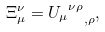Convert formula to latex. <formula><loc_0><loc_0><loc_500><loc_500>\Xi ^ { \nu } _ { \mu } = { { U _ { \mu } } ^ { \nu \rho } } _ { , \rho } ,</formula> 